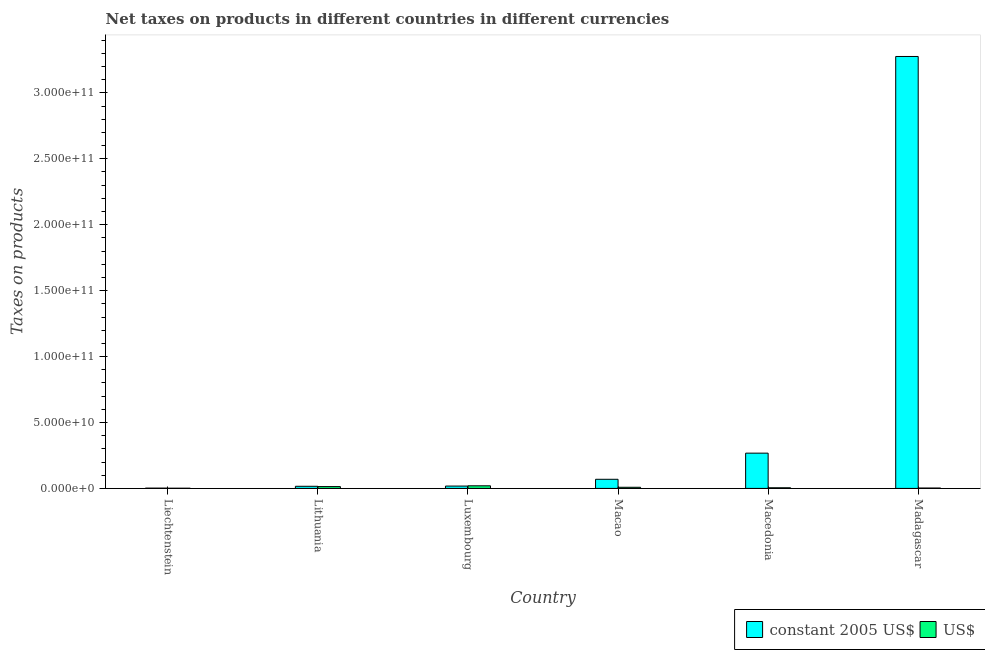How many different coloured bars are there?
Your answer should be compact. 2. Are the number of bars per tick equal to the number of legend labels?
Provide a short and direct response. Yes. Are the number of bars on each tick of the X-axis equal?
Keep it short and to the point. Yes. How many bars are there on the 1st tick from the left?
Your answer should be very brief. 2. What is the label of the 3rd group of bars from the left?
Ensure brevity in your answer.  Luxembourg. What is the net taxes in us$ in Madagascar?
Your answer should be compact. 3.01e+08. Across all countries, what is the maximum net taxes in us$?
Your answer should be very brief. 1.98e+09. Across all countries, what is the minimum net taxes in us$?
Offer a very short reply. 1.54e+08. In which country was the net taxes in us$ maximum?
Provide a succinct answer. Luxembourg. In which country was the net taxes in us$ minimum?
Give a very brief answer. Liechtenstein. What is the total net taxes in us$ in the graph?
Provide a short and direct response. 5.18e+09. What is the difference between the net taxes in constant 2005 us$ in Macao and that in Macedonia?
Your answer should be compact. -1.98e+1. What is the difference between the net taxes in constant 2005 us$ in Luxembourg and the net taxes in us$ in Liechtenstein?
Offer a very short reply. 1.62e+09. What is the average net taxes in us$ per country?
Offer a very short reply. 8.63e+08. What is the difference between the net taxes in us$ and net taxes in constant 2005 us$ in Macao?
Your answer should be very brief. -6.05e+09. What is the ratio of the net taxes in constant 2005 us$ in Liechtenstein to that in Lithuania?
Provide a short and direct response. 0.14. Is the net taxes in constant 2005 us$ in Liechtenstein less than that in Macao?
Make the answer very short. Yes. Is the difference between the net taxes in constant 2005 us$ in Liechtenstein and Luxembourg greater than the difference between the net taxes in us$ in Liechtenstein and Luxembourg?
Provide a short and direct response. Yes. What is the difference between the highest and the second highest net taxes in us$?
Make the answer very short. 5.87e+08. What is the difference between the highest and the lowest net taxes in us$?
Your response must be concise. 1.82e+09. Is the sum of the net taxes in us$ in Luxembourg and Madagascar greater than the maximum net taxes in constant 2005 us$ across all countries?
Make the answer very short. No. What does the 2nd bar from the left in Madagascar represents?
Ensure brevity in your answer.  US$. What does the 1st bar from the right in Luxembourg represents?
Offer a terse response. US$. How many bars are there?
Your answer should be compact. 12. How many countries are there in the graph?
Provide a succinct answer. 6. What is the difference between two consecutive major ticks on the Y-axis?
Provide a succinct answer. 5.00e+1. Does the graph contain any zero values?
Offer a terse response. No. Where does the legend appear in the graph?
Offer a very short reply. Bottom right. What is the title of the graph?
Offer a terse response. Net taxes on products in different countries in different currencies. Does "From production" appear as one of the legend labels in the graph?
Provide a short and direct response. No. What is the label or title of the Y-axis?
Keep it short and to the point. Taxes on products. What is the Taxes on products of constant 2005 US$ in Liechtenstein?
Make the answer very short. 2.23e+08. What is the Taxes on products in US$ in Liechtenstein?
Offer a very short reply. 1.54e+08. What is the Taxes on products of constant 2005 US$ in Lithuania?
Your response must be concise. 1.61e+09. What is the Taxes on products of US$ in Lithuania?
Make the answer very short. 1.39e+09. What is the Taxes on products of constant 2005 US$ in Luxembourg?
Give a very brief answer. 1.78e+09. What is the Taxes on products of US$ in Luxembourg?
Offer a terse response. 1.98e+09. What is the Taxes on products of constant 2005 US$ in Macao?
Ensure brevity in your answer.  6.92e+09. What is the Taxes on products of US$ in Macao?
Give a very brief answer. 8.67e+08. What is the Taxes on products in constant 2005 US$ in Macedonia?
Offer a very short reply. 2.67e+1. What is the Taxes on products of US$ in Macedonia?
Make the answer very short. 4.90e+08. What is the Taxes on products in constant 2005 US$ in Madagascar?
Ensure brevity in your answer.  3.28e+11. What is the Taxes on products of US$ in Madagascar?
Your answer should be very brief. 3.01e+08. Across all countries, what is the maximum Taxes on products in constant 2005 US$?
Keep it short and to the point. 3.28e+11. Across all countries, what is the maximum Taxes on products in US$?
Your answer should be very brief. 1.98e+09. Across all countries, what is the minimum Taxes on products in constant 2005 US$?
Provide a succinct answer. 2.23e+08. Across all countries, what is the minimum Taxes on products in US$?
Ensure brevity in your answer.  1.54e+08. What is the total Taxes on products of constant 2005 US$ in the graph?
Offer a very short reply. 3.65e+11. What is the total Taxes on products in US$ in the graph?
Offer a very short reply. 5.18e+09. What is the difference between the Taxes on products in constant 2005 US$ in Liechtenstein and that in Lithuania?
Make the answer very short. -1.39e+09. What is the difference between the Taxes on products in US$ in Liechtenstein and that in Lithuania?
Your answer should be compact. -1.24e+09. What is the difference between the Taxes on products of constant 2005 US$ in Liechtenstein and that in Luxembourg?
Make the answer very short. -1.55e+09. What is the difference between the Taxes on products of US$ in Liechtenstein and that in Luxembourg?
Make the answer very short. -1.82e+09. What is the difference between the Taxes on products in constant 2005 US$ in Liechtenstein and that in Macao?
Keep it short and to the point. -6.69e+09. What is the difference between the Taxes on products of US$ in Liechtenstein and that in Macao?
Make the answer very short. -7.13e+08. What is the difference between the Taxes on products of constant 2005 US$ in Liechtenstein and that in Macedonia?
Ensure brevity in your answer.  -2.65e+1. What is the difference between the Taxes on products of US$ in Liechtenstein and that in Macedonia?
Provide a succinct answer. -3.36e+08. What is the difference between the Taxes on products in constant 2005 US$ in Liechtenstein and that in Madagascar?
Your response must be concise. -3.27e+11. What is the difference between the Taxes on products in US$ in Liechtenstein and that in Madagascar?
Keep it short and to the point. -1.47e+08. What is the difference between the Taxes on products of constant 2005 US$ in Lithuania and that in Luxembourg?
Your answer should be compact. -1.69e+08. What is the difference between the Taxes on products in US$ in Lithuania and that in Luxembourg?
Offer a terse response. -5.87e+08. What is the difference between the Taxes on products in constant 2005 US$ in Lithuania and that in Macao?
Keep it short and to the point. -5.31e+09. What is the difference between the Taxes on products of US$ in Lithuania and that in Macao?
Your answer should be very brief. 5.22e+08. What is the difference between the Taxes on products of constant 2005 US$ in Lithuania and that in Macedonia?
Make the answer very short. -2.51e+1. What is the difference between the Taxes on products of US$ in Lithuania and that in Macedonia?
Make the answer very short. 8.99e+08. What is the difference between the Taxes on products of constant 2005 US$ in Lithuania and that in Madagascar?
Make the answer very short. -3.26e+11. What is the difference between the Taxes on products of US$ in Lithuania and that in Madagascar?
Offer a terse response. 1.09e+09. What is the difference between the Taxes on products in constant 2005 US$ in Luxembourg and that in Macao?
Your response must be concise. -5.14e+09. What is the difference between the Taxes on products in US$ in Luxembourg and that in Macao?
Provide a short and direct response. 1.11e+09. What is the difference between the Taxes on products of constant 2005 US$ in Luxembourg and that in Macedonia?
Offer a terse response. -2.50e+1. What is the difference between the Taxes on products in US$ in Luxembourg and that in Macedonia?
Make the answer very short. 1.49e+09. What is the difference between the Taxes on products of constant 2005 US$ in Luxembourg and that in Madagascar?
Give a very brief answer. -3.26e+11. What is the difference between the Taxes on products of US$ in Luxembourg and that in Madagascar?
Provide a short and direct response. 1.67e+09. What is the difference between the Taxes on products of constant 2005 US$ in Macao and that in Macedonia?
Your answer should be very brief. -1.98e+1. What is the difference between the Taxes on products in US$ in Macao and that in Macedonia?
Offer a terse response. 3.77e+08. What is the difference between the Taxes on products in constant 2005 US$ in Macao and that in Madagascar?
Ensure brevity in your answer.  -3.21e+11. What is the difference between the Taxes on products in US$ in Macao and that in Madagascar?
Offer a terse response. 5.66e+08. What is the difference between the Taxes on products in constant 2005 US$ in Macedonia and that in Madagascar?
Make the answer very short. -3.01e+11. What is the difference between the Taxes on products of US$ in Macedonia and that in Madagascar?
Provide a short and direct response. 1.89e+08. What is the difference between the Taxes on products in constant 2005 US$ in Liechtenstein and the Taxes on products in US$ in Lithuania?
Offer a terse response. -1.17e+09. What is the difference between the Taxes on products of constant 2005 US$ in Liechtenstein and the Taxes on products of US$ in Luxembourg?
Provide a short and direct response. -1.75e+09. What is the difference between the Taxes on products in constant 2005 US$ in Liechtenstein and the Taxes on products in US$ in Macao?
Ensure brevity in your answer.  -6.44e+08. What is the difference between the Taxes on products in constant 2005 US$ in Liechtenstein and the Taxes on products in US$ in Macedonia?
Ensure brevity in your answer.  -2.67e+08. What is the difference between the Taxes on products in constant 2005 US$ in Liechtenstein and the Taxes on products in US$ in Madagascar?
Offer a terse response. -7.82e+07. What is the difference between the Taxes on products of constant 2005 US$ in Lithuania and the Taxes on products of US$ in Luxembourg?
Offer a very short reply. -3.67e+08. What is the difference between the Taxes on products in constant 2005 US$ in Lithuania and the Taxes on products in US$ in Macao?
Provide a short and direct response. 7.42e+08. What is the difference between the Taxes on products of constant 2005 US$ in Lithuania and the Taxes on products of US$ in Macedonia?
Make the answer very short. 1.12e+09. What is the difference between the Taxes on products in constant 2005 US$ in Lithuania and the Taxes on products in US$ in Madagascar?
Give a very brief answer. 1.31e+09. What is the difference between the Taxes on products of constant 2005 US$ in Luxembourg and the Taxes on products of US$ in Macao?
Make the answer very short. 9.11e+08. What is the difference between the Taxes on products of constant 2005 US$ in Luxembourg and the Taxes on products of US$ in Macedonia?
Your response must be concise. 1.29e+09. What is the difference between the Taxes on products of constant 2005 US$ in Luxembourg and the Taxes on products of US$ in Madagascar?
Make the answer very short. 1.48e+09. What is the difference between the Taxes on products of constant 2005 US$ in Macao and the Taxes on products of US$ in Macedonia?
Offer a very short reply. 6.43e+09. What is the difference between the Taxes on products of constant 2005 US$ in Macao and the Taxes on products of US$ in Madagascar?
Provide a short and direct response. 6.62e+09. What is the difference between the Taxes on products in constant 2005 US$ in Macedonia and the Taxes on products in US$ in Madagascar?
Offer a very short reply. 2.64e+1. What is the average Taxes on products of constant 2005 US$ per country?
Your response must be concise. 6.08e+1. What is the average Taxes on products in US$ per country?
Keep it short and to the point. 8.63e+08. What is the difference between the Taxes on products of constant 2005 US$ and Taxes on products of US$ in Liechtenstein?
Make the answer very short. 6.91e+07. What is the difference between the Taxes on products of constant 2005 US$ and Taxes on products of US$ in Lithuania?
Your response must be concise. 2.20e+08. What is the difference between the Taxes on products in constant 2005 US$ and Taxes on products in US$ in Luxembourg?
Give a very brief answer. -1.98e+08. What is the difference between the Taxes on products of constant 2005 US$ and Taxes on products of US$ in Macao?
Keep it short and to the point. 6.05e+09. What is the difference between the Taxes on products of constant 2005 US$ and Taxes on products of US$ in Macedonia?
Your answer should be compact. 2.63e+1. What is the difference between the Taxes on products in constant 2005 US$ and Taxes on products in US$ in Madagascar?
Your answer should be very brief. 3.27e+11. What is the ratio of the Taxes on products in constant 2005 US$ in Liechtenstein to that in Lithuania?
Your answer should be very brief. 0.14. What is the ratio of the Taxes on products of US$ in Liechtenstein to that in Lithuania?
Make the answer very short. 0.11. What is the ratio of the Taxes on products in constant 2005 US$ in Liechtenstein to that in Luxembourg?
Your answer should be very brief. 0.13. What is the ratio of the Taxes on products of US$ in Liechtenstein to that in Luxembourg?
Provide a short and direct response. 0.08. What is the ratio of the Taxes on products in constant 2005 US$ in Liechtenstein to that in Macao?
Offer a terse response. 0.03. What is the ratio of the Taxes on products of US$ in Liechtenstein to that in Macao?
Provide a short and direct response. 0.18. What is the ratio of the Taxes on products in constant 2005 US$ in Liechtenstein to that in Macedonia?
Give a very brief answer. 0.01. What is the ratio of the Taxes on products of US$ in Liechtenstein to that in Macedonia?
Provide a short and direct response. 0.31. What is the ratio of the Taxes on products of constant 2005 US$ in Liechtenstein to that in Madagascar?
Your answer should be compact. 0. What is the ratio of the Taxes on products in US$ in Liechtenstein to that in Madagascar?
Ensure brevity in your answer.  0.51. What is the ratio of the Taxes on products in constant 2005 US$ in Lithuania to that in Luxembourg?
Provide a succinct answer. 0.91. What is the ratio of the Taxes on products in US$ in Lithuania to that in Luxembourg?
Make the answer very short. 0.7. What is the ratio of the Taxes on products in constant 2005 US$ in Lithuania to that in Macao?
Your answer should be compact. 0.23. What is the ratio of the Taxes on products of US$ in Lithuania to that in Macao?
Ensure brevity in your answer.  1.6. What is the ratio of the Taxes on products in constant 2005 US$ in Lithuania to that in Macedonia?
Provide a succinct answer. 0.06. What is the ratio of the Taxes on products of US$ in Lithuania to that in Macedonia?
Your answer should be compact. 2.84. What is the ratio of the Taxes on products of constant 2005 US$ in Lithuania to that in Madagascar?
Your answer should be compact. 0. What is the ratio of the Taxes on products of US$ in Lithuania to that in Madagascar?
Your response must be concise. 4.61. What is the ratio of the Taxes on products in constant 2005 US$ in Luxembourg to that in Macao?
Ensure brevity in your answer.  0.26. What is the ratio of the Taxes on products in US$ in Luxembourg to that in Macao?
Your answer should be compact. 2.28. What is the ratio of the Taxes on products in constant 2005 US$ in Luxembourg to that in Macedonia?
Offer a very short reply. 0.07. What is the ratio of the Taxes on products of US$ in Luxembourg to that in Macedonia?
Give a very brief answer. 4.03. What is the ratio of the Taxes on products in constant 2005 US$ in Luxembourg to that in Madagascar?
Provide a succinct answer. 0.01. What is the ratio of the Taxes on products of US$ in Luxembourg to that in Madagascar?
Offer a terse response. 6.56. What is the ratio of the Taxes on products of constant 2005 US$ in Macao to that in Macedonia?
Make the answer very short. 0.26. What is the ratio of the Taxes on products in US$ in Macao to that in Macedonia?
Make the answer very short. 1.77. What is the ratio of the Taxes on products in constant 2005 US$ in Macao to that in Madagascar?
Your response must be concise. 0.02. What is the ratio of the Taxes on products of US$ in Macao to that in Madagascar?
Ensure brevity in your answer.  2.88. What is the ratio of the Taxes on products in constant 2005 US$ in Macedonia to that in Madagascar?
Ensure brevity in your answer.  0.08. What is the ratio of the Taxes on products of US$ in Macedonia to that in Madagascar?
Provide a short and direct response. 1.63. What is the difference between the highest and the second highest Taxes on products in constant 2005 US$?
Your response must be concise. 3.01e+11. What is the difference between the highest and the second highest Taxes on products in US$?
Ensure brevity in your answer.  5.87e+08. What is the difference between the highest and the lowest Taxes on products in constant 2005 US$?
Your answer should be very brief. 3.27e+11. What is the difference between the highest and the lowest Taxes on products of US$?
Provide a short and direct response. 1.82e+09. 